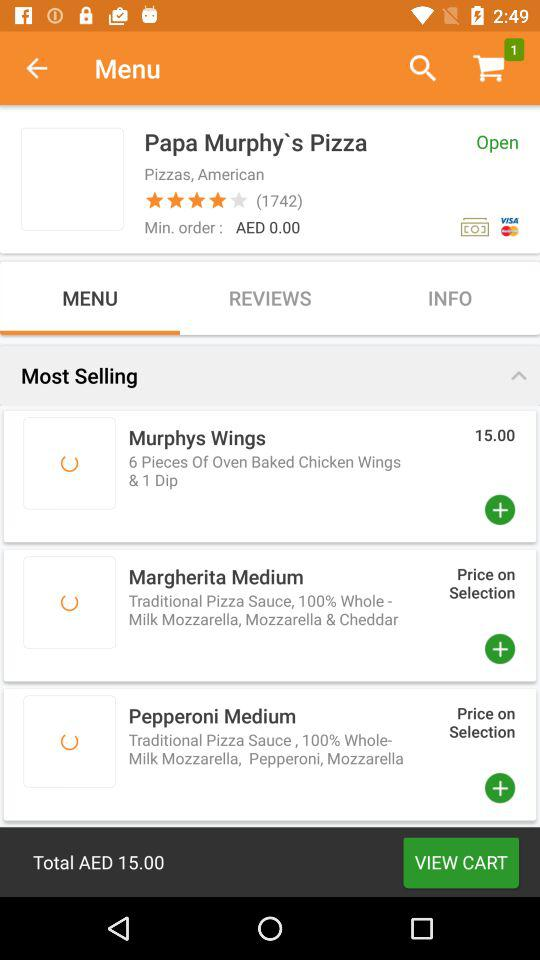Which tab is selected? The selected tab is "MENU". 